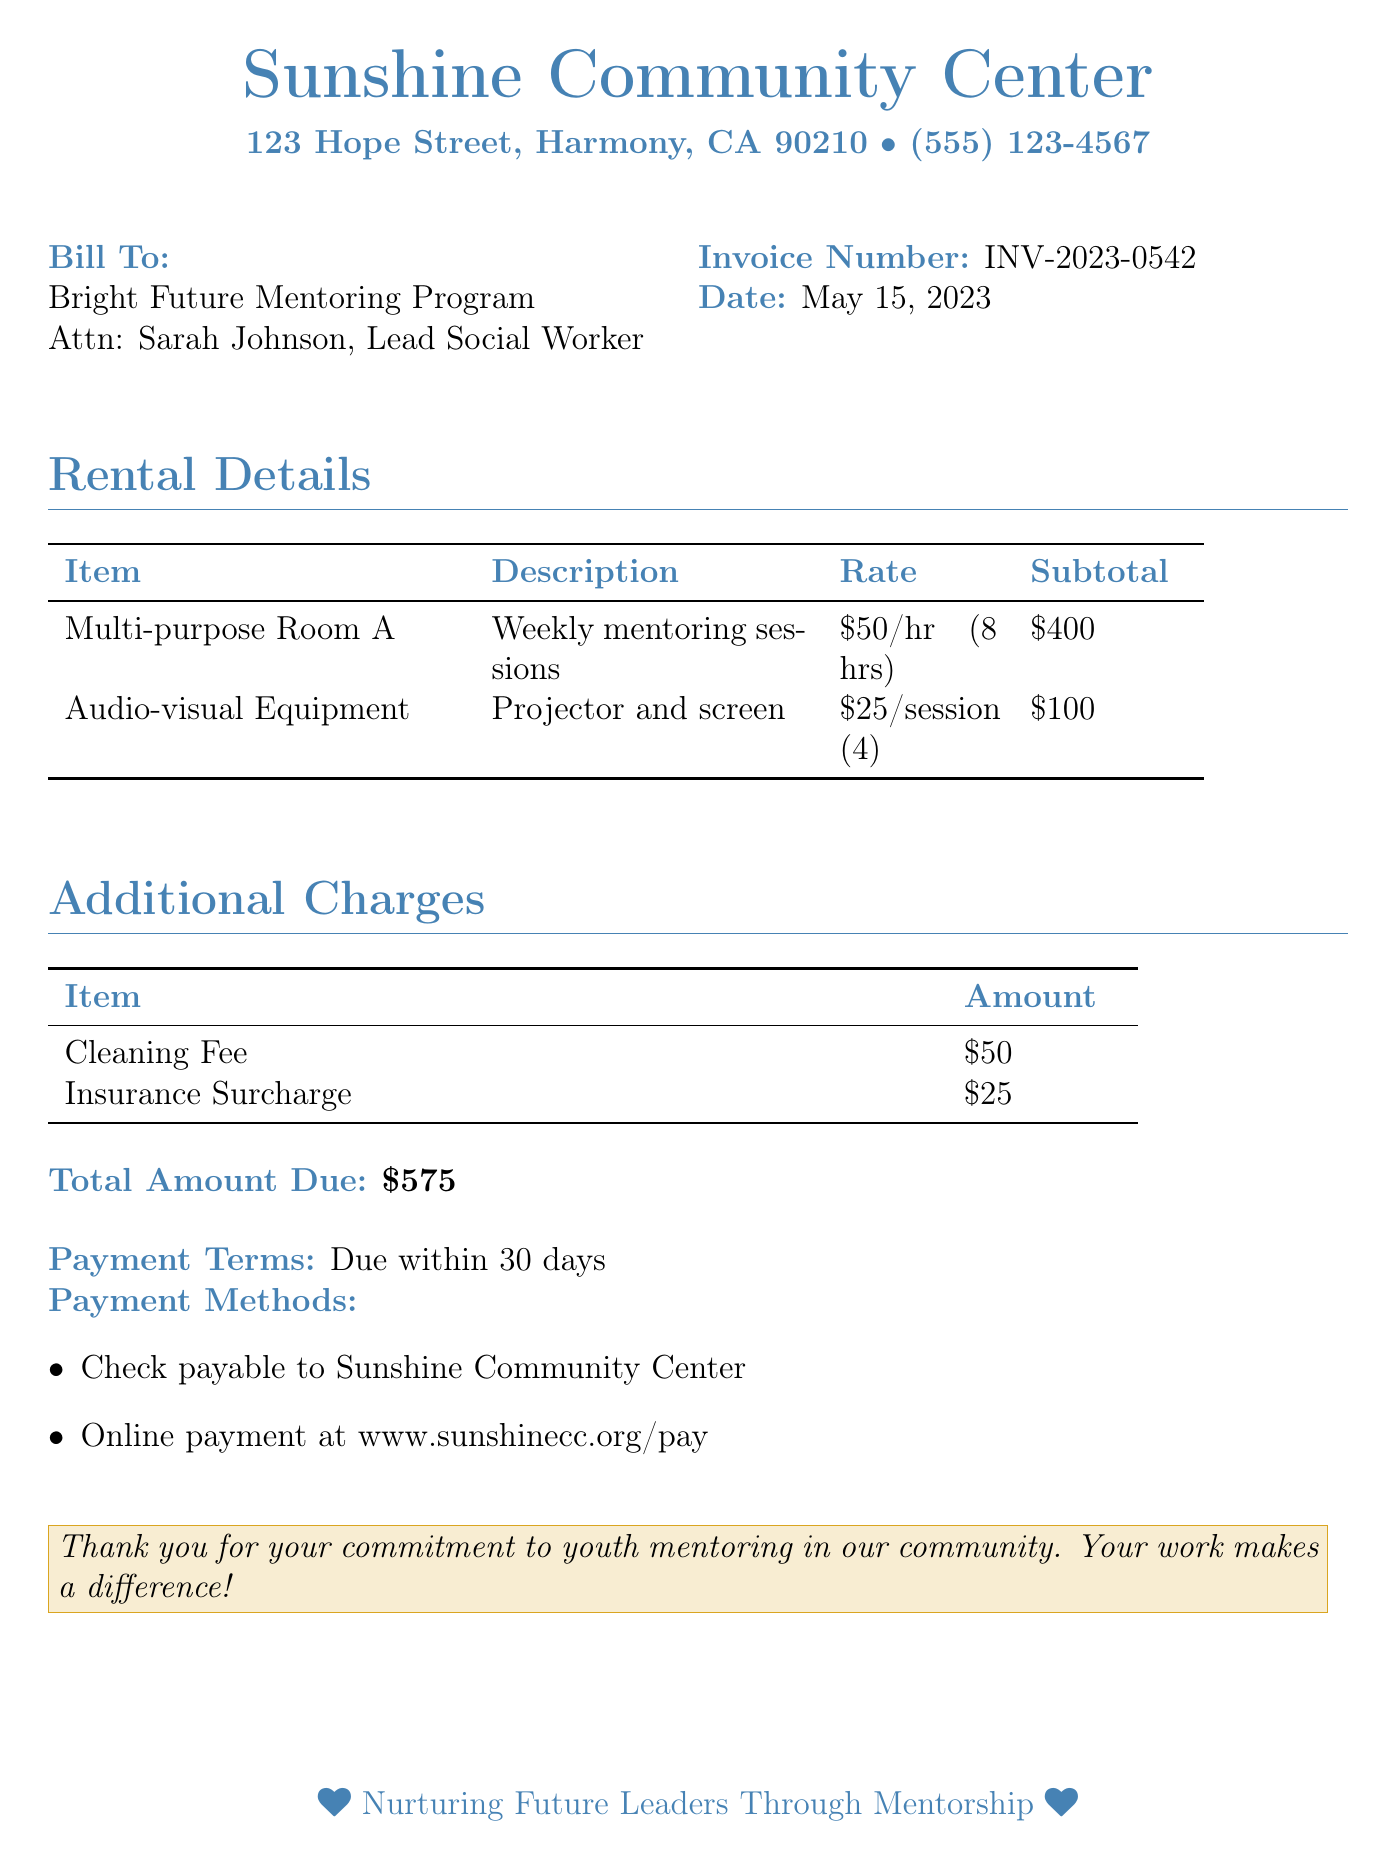What is the invoice number? The invoice number can be found in the header section of the bill, labeled as "Invoice Number."
Answer: INV-2023-0542 What is the total amount due? The total amount due is stated at the end of the bill under "Total Amount Due."
Answer: $575 Who is the bill addressed to? The recipient of the bill is indicated in the "Bill To" section.
Answer: Bright Future Mentoring Program What is the rental rate for the multi-purpose room? The rental rate for the multi-purpose room can be found in the "Rental Details" section.
Answer: $50/hr (8 hrs) How many sessions were charged for audio-visual equipment? The number of sessions for the audio-visual equipment is specified in the "Rental Details" section.
Answer: 4 What is the cleaning fee amount? The cleaning fee is listed under "Additional Charges."
Answer: $50 What is the date of the invoice? The date is provided in the header section of the bill.
Answer: May 15, 2023 What is the duration of the mentoring sessions held in the multi-purpose room? The duration is mentioned in the description of the multi-purpose room rental details.
Answer: 8 hrs 